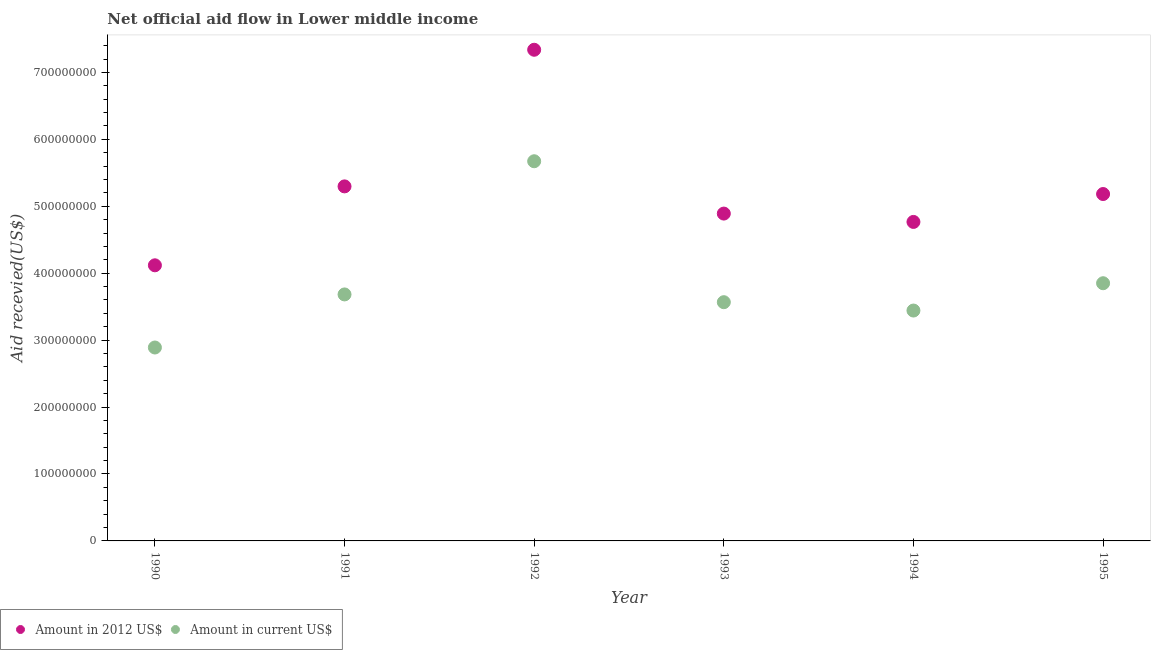Is the number of dotlines equal to the number of legend labels?
Give a very brief answer. Yes. What is the amount of aid received(expressed in 2012 us$) in 1993?
Your answer should be very brief. 4.89e+08. Across all years, what is the maximum amount of aid received(expressed in us$)?
Give a very brief answer. 5.67e+08. Across all years, what is the minimum amount of aid received(expressed in us$)?
Provide a succinct answer. 2.89e+08. In which year was the amount of aid received(expressed in 2012 us$) maximum?
Your answer should be very brief. 1992. In which year was the amount of aid received(expressed in 2012 us$) minimum?
Make the answer very short. 1990. What is the total amount of aid received(expressed in us$) in the graph?
Your answer should be compact. 2.31e+09. What is the difference between the amount of aid received(expressed in 2012 us$) in 1991 and that in 1993?
Provide a succinct answer. 4.06e+07. What is the difference between the amount of aid received(expressed in us$) in 1995 and the amount of aid received(expressed in 2012 us$) in 1992?
Make the answer very short. -3.49e+08. What is the average amount of aid received(expressed in us$) per year?
Your answer should be compact. 3.85e+08. In the year 1990, what is the difference between the amount of aid received(expressed in 2012 us$) and amount of aid received(expressed in us$)?
Ensure brevity in your answer.  1.23e+08. What is the ratio of the amount of aid received(expressed in us$) in 1990 to that in 1995?
Your answer should be compact. 0.75. Is the difference between the amount of aid received(expressed in us$) in 1993 and 1994 greater than the difference between the amount of aid received(expressed in 2012 us$) in 1993 and 1994?
Offer a very short reply. Yes. What is the difference between the highest and the second highest amount of aid received(expressed in us$)?
Offer a terse response. 1.82e+08. What is the difference between the highest and the lowest amount of aid received(expressed in us$)?
Make the answer very short. 2.78e+08. Is the amount of aid received(expressed in 2012 us$) strictly greater than the amount of aid received(expressed in us$) over the years?
Your answer should be very brief. Yes. What is the difference between two consecutive major ticks on the Y-axis?
Ensure brevity in your answer.  1.00e+08. Are the values on the major ticks of Y-axis written in scientific E-notation?
Offer a terse response. No. Where does the legend appear in the graph?
Keep it short and to the point. Bottom left. What is the title of the graph?
Ensure brevity in your answer.  Net official aid flow in Lower middle income. Does "By country of asylum" appear as one of the legend labels in the graph?
Keep it short and to the point. No. What is the label or title of the Y-axis?
Your answer should be very brief. Aid recevied(US$). What is the Aid recevied(US$) of Amount in 2012 US$ in 1990?
Your response must be concise. 4.12e+08. What is the Aid recevied(US$) of Amount in current US$ in 1990?
Keep it short and to the point. 2.89e+08. What is the Aid recevied(US$) in Amount in 2012 US$ in 1991?
Provide a succinct answer. 5.30e+08. What is the Aid recevied(US$) of Amount in current US$ in 1991?
Your answer should be compact. 3.68e+08. What is the Aid recevied(US$) of Amount in 2012 US$ in 1992?
Offer a terse response. 7.34e+08. What is the Aid recevied(US$) in Amount in current US$ in 1992?
Your answer should be compact. 5.67e+08. What is the Aid recevied(US$) in Amount in 2012 US$ in 1993?
Give a very brief answer. 4.89e+08. What is the Aid recevied(US$) of Amount in current US$ in 1993?
Provide a succinct answer. 3.57e+08. What is the Aid recevied(US$) of Amount in 2012 US$ in 1994?
Ensure brevity in your answer.  4.77e+08. What is the Aid recevied(US$) in Amount in current US$ in 1994?
Your answer should be compact. 3.44e+08. What is the Aid recevied(US$) of Amount in 2012 US$ in 1995?
Give a very brief answer. 5.18e+08. What is the Aid recevied(US$) of Amount in current US$ in 1995?
Your response must be concise. 3.85e+08. Across all years, what is the maximum Aid recevied(US$) of Amount in 2012 US$?
Provide a succinct answer. 7.34e+08. Across all years, what is the maximum Aid recevied(US$) of Amount in current US$?
Offer a terse response. 5.67e+08. Across all years, what is the minimum Aid recevied(US$) in Amount in 2012 US$?
Provide a succinct answer. 4.12e+08. Across all years, what is the minimum Aid recevied(US$) in Amount in current US$?
Keep it short and to the point. 2.89e+08. What is the total Aid recevied(US$) of Amount in 2012 US$ in the graph?
Your answer should be compact. 3.16e+09. What is the total Aid recevied(US$) in Amount in current US$ in the graph?
Your answer should be compact. 2.31e+09. What is the difference between the Aid recevied(US$) in Amount in 2012 US$ in 1990 and that in 1991?
Your answer should be very brief. -1.18e+08. What is the difference between the Aid recevied(US$) in Amount in current US$ in 1990 and that in 1991?
Provide a succinct answer. -7.93e+07. What is the difference between the Aid recevied(US$) of Amount in 2012 US$ in 1990 and that in 1992?
Provide a short and direct response. -3.22e+08. What is the difference between the Aid recevied(US$) in Amount in current US$ in 1990 and that in 1992?
Keep it short and to the point. -2.78e+08. What is the difference between the Aid recevied(US$) of Amount in 2012 US$ in 1990 and that in 1993?
Your answer should be very brief. -7.73e+07. What is the difference between the Aid recevied(US$) of Amount in current US$ in 1990 and that in 1993?
Offer a very short reply. -6.77e+07. What is the difference between the Aid recevied(US$) of Amount in 2012 US$ in 1990 and that in 1994?
Your answer should be compact. -6.48e+07. What is the difference between the Aid recevied(US$) of Amount in current US$ in 1990 and that in 1994?
Ensure brevity in your answer.  -5.52e+07. What is the difference between the Aid recevied(US$) in Amount in 2012 US$ in 1990 and that in 1995?
Offer a very short reply. -1.06e+08. What is the difference between the Aid recevied(US$) in Amount in current US$ in 1990 and that in 1995?
Make the answer very short. -9.60e+07. What is the difference between the Aid recevied(US$) of Amount in 2012 US$ in 1991 and that in 1992?
Your answer should be very brief. -2.04e+08. What is the difference between the Aid recevied(US$) in Amount in current US$ in 1991 and that in 1992?
Keep it short and to the point. -1.99e+08. What is the difference between the Aid recevied(US$) in Amount in 2012 US$ in 1991 and that in 1993?
Your answer should be compact. 4.06e+07. What is the difference between the Aid recevied(US$) of Amount in current US$ in 1991 and that in 1993?
Offer a very short reply. 1.16e+07. What is the difference between the Aid recevied(US$) in Amount in 2012 US$ in 1991 and that in 1994?
Make the answer very short. 5.31e+07. What is the difference between the Aid recevied(US$) in Amount in current US$ in 1991 and that in 1994?
Your response must be concise. 2.41e+07. What is the difference between the Aid recevied(US$) in Amount in 2012 US$ in 1991 and that in 1995?
Provide a succinct answer. 1.14e+07. What is the difference between the Aid recevied(US$) in Amount in current US$ in 1991 and that in 1995?
Offer a terse response. -1.67e+07. What is the difference between the Aid recevied(US$) of Amount in 2012 US$ in 1992 and that in 1993?
Provide a short and direct response. 2.45e+08. What is the difference between the Aid recevied(US$) of Amount in current US$ in 1992 and that in 1993?
Your response must be concise. 2.11e+08. What is the difference between the Aid recevied(US$) in Amount in 2012 US$ in 1992 and that in 1994?
Your response must be concise. 2.57e+08. What is the difference between the Aid recevied(US$) of Amount in current US$ in 1992 and that in 1994?
Your response must be concise. 2.23e+08. What is the difference between the Aid recevied(US$) of Amount in 2012 US$ in 1992 and that in 1995?
Your response must be concise. 2.16e+08. What is the difference between the Aid recevied(US$) in Amount in current US$ in 1992 and that in 1995?
Your answer should be compact. 1.82e+08. What is the difference between the Aid recevied(US$) of Amount in 2012 US$ in 1993 and that in 1994?
Offer a very short reply. 1.25e+07. What is the difference between the Aid recevied(US$) of Amount in current US$ in 1993 and that in 1994?
Provide a short and direct response. 1.25e+07. What is the difference between the Aid recevied(US$) in Amount in 2012 US$ in 1993 and that in 1995?
Make the answer very short. -2.92e+07. What is the difference between the Aid recevied(US$) in Amount in current US$ in 1993 and that in 1995?
Give a very brief answer. -2.83e+07. What is the difference between the Aid recevied(US$) in Amount in 2012 US$ in 1994 and that in 1995?
Your response must be concise. -4.17e+07. What is the difference between the Aid recevied(US$) of Amount in current US$ in 1994 and that in 1995?
Give a very brief answer. -4.08e+07. What is the difference between the Aid recevied(US$) in Amount in 2012 US$ in 1990 and the Aid recevied(US$) in Amount in current US$ in 1991?
Your response must be concise. 4.35e+07. What is the difference between the Aid recevied(US$) of Amount in 2012 US$ in 1990 and the Aid recevied(US$) of Amount in current US$ in 1992?
Your answer should be very brief. -1.55e+08. What is the difference between the Aid recevied(US$) of Amount in 2012 US$ in 1990 and the Aid recevied(US$) of Amount in current US$ in 1993?
Your answer should be very brief. 5.51e+07. What is the difference between the Aid recevied(US$) of Amount in 2012 US$ in 1990 and the Aid recevied(US$) of Amount in current US$ in 1994?
Your answer should be very brief. 6.76e+07. What is the difference between the Aid recevied(US$) in Amount in 2012 US$ in 1990 and the Aid recevied(US$) in Amount in current US$ in 1995?
Keep it short and to the point. 2.68e+07. What is the difference between the Aid recevied(US$) in Amount in 2012 US$ in 1991 and the Aid recevied(US$) in Amount in current US$ in 1992?
Your answer should be very brief. -3.76e+07. What is the difference between the Aid recevied(US$) of Amount in 2012 US$ in 1991 and the Aid recevied(US$) of Amount in current US$ in 1993?
Your answer should be compact. 1.73e+08. What is the difference between the Aid recevied(US$) in Amount in 2012 US$ in 1991 and the Aid recevied(US$) in Amount in current US$ in 1994?
Keep it short and to the point. 1.86e+08. What is the difference between the Aid recevied(US$) in Amount in 2012 US$ in 1991 and the Aid recevied(US$) in Amount in current US$ in 1995?
Provide a short and direct response. 1.45e+08. What is the difference between the Aid recevied(US$) in Amount in 2012 US$ in 1992 and the Aid recevied(US$) in Amount in current US$ in 1993?
Keep it short and to the point. 3.77e+08. What is the difference between the Aid recevied(US$) in Amount in 2012 US$ in 1992 and the Aid recevied(US$) in Amount in current US$ in 1994?
Your response must be concise. 3.90e+08. What is the difference between the Aid recevied(US$) of Amount in 2012 US$ in 1992 and the Aid recevied(US$) of Amount in current US$ in 1995?
Offer a terse response. 3.49e+08. What is the difference between the Aid recevied(US$) in Amount in 2012 US$ in 1993 and the Aid recevied(US$) in Amount in current US$ in 1994?
Provide a succinct answer. 1.45e+08. What is the difference between the Aid recevied(US$) in Amount in 2012 US$ in 1993 and the Aid recevied(US$) in Amount in current US$ in 1995?
Provide a short and direct response. 1.04e+08. What is the difference between the Aid recevied(US$) of Amount in 2012 US$ in 1994 and the Aid recevied(US$) of Amount in current US$ in 1995?
Your answer should be very brief. 9.16e+07. What is the average Aid recevied(US$) in Amount in 2012 US$ per year?
Offer a terse response. 5.27e+08. What is the average Aid recevied(US$) of Amount in current US$ per year?
Keep it short and to the point. 3.85e+08. In the year 1990, what is the difference between the Aid recevied(US$) of Amount in 2012 US$ and Aid recevied(US$) of Amount in current US$?
Give a very brief answer. 1.23e+08. In the year 1991, what is the difference between the Aid recevied(US$) of Amount in 2012 US$ and Aid recevied(US$) of Amount in current US$?
Provide a short and direct response. 1.61e+08. In the year 1992, what is the difference between the Aid recevied(US$) in Amount in 2012 US$ and Aid recevied(US$) in Amount in current US$?
Offer a very short reply. 1.67e+08. In the year 1993, what is the difference between the Aid recevied(US$) in Amount in 2012 US$ and Aid recevied(US$) in Amount in current US$?
Your answer should be compact. 1.32e+08. In the year 1994, what is the difference between the Aid recevied(US$) of Amount in 2012 US$ and Aid recevied(US$) of Amount in current US$?
Give a very brief answer. 1.32e+08. In the year 1995, what is the difference between the Aid recevied(US$) in Amount in 2012 US$ and Aid recevied(US$) in Amount in current US$?
Ensure brevity in your answer.  1.33e+08. What is the ratio of the Aid recevied(US$) of Amount in 2012 US$ in 1990 to that in 1991?
Give a very brief answer. 0.78. What is the ratio of the Aid recevied(US$) in Amount in current US$ in 1990 to that in 1991?
Offer a terse response. 0.78. What is the ratio of the Aid recevied(US$) in Amount in 2012 US$ in 1990 to that in 1992?
Give a very brief answer. 0.56. What is the ratio of the Aid recevied(US$) in Amount in current US$ in 1990 to that in 1992?
Your answer should be compact. 0.51. What is the ratio of the Aid recevied(US$) of Amount in 2012 US$ in 1990 to that in 1993?
Make the answer very short. 0.84. What is the ratio of the Aid recevied(US$) of Amount in current US$ in 1990 to that in 1993?
Give a very brief answer. 0.81. What is the ratio of the Aid recevied(US$) in Amount in 2012 US$ in 1990 to that in 1994?
Ensure brevity in your answer.  0.86. What is the ratio of the Aid recevied(US$) of Amount in current US$ in 1990 to that in 1994?
Your answer should be very brief. 0.84. What is the ratio of the Aid recevied(US$) in Amount in 2012 US$ in 1990 to that in 1995?
Keep it short and to the point. 0.79. What is the ratio of the Aid recevied(US$) in Amount in current US$ in 1990 to that in 1995?
Your response must be concise. 0.75. What is the ratio of the Aid recevied(US$) of Amount in 2012 US$ in 1991 to that in 1992?
Your response must be concise. 0.72. What is the ratio of the Aid recevied(US$) of Amount in current US$ in 1991 to that in 1992?
Give a very brief answer. 0.65. What is the ratio of the Aid recevied(US$) in Amount in 2012 US$ in 1991 to that in 1993?
Keep it short and to the point. 1.08. What is the ratio of the Aid recevied(US$) in Amount in current US$ in 1991 to that in 1993?
Keep it short and to the point. 1.03. What is the ratio of the Aid recevied(US$) in Amount in 2012 US$ in 1991 to that in 1994?
Your answer should be very brief. 1.11. What is the ratio of the Aid recevied(US$) of Amount in current US$ in 1991 to that in 1994?
Provide a short and direct response. 1.07. What is the ratio of the Aid recevied(US$) of Amount in current US$ in 1991 to that in 1995?
Offer a very short reply. 0.96. What is the ratio of the Aid recevied(US$) of Amount in 2012 US$ in 1992 to that in 1993?
Give a very brief answer. 1.5. What is the ratio of the Aid recevied(US$) of Amount in current US$ in 1992 to that in 1993?
Ensure brevity in your answer.  1.59. What is the ratio of the Aid recevied(US$) of Amount in 2012 US$ in 1992 to that in 1994?
Provide a succinct answer. 1.54. What is the ratio of the Aid recevied(US$) in Amount in current US$ in 1992 to that in 1994?
Ensure brevity in your answer.  1.65. What is the ratio of the Aid recevied(US$) of Amount in 2012 US$ in 1992 to that in 1995?
Make the answer very short. 1.42. What is the ratio of the Aid recevied(US$) in Amount in current US$ in 1992 to that in 1995?
Your response must be concise. 1.47. What is the ratio of the Aid recevied(US$) in Amount in 2012 US$ in 1993 to that in 1994?
Your answer should be very brief. 1.03. What is the ratio of the Aid recevied(US$) of Amount in current US$ in 1993 to that in 1994?
Your response must be concise. 1.04. What is the ratio of the Aid recevied(US$) in Amount in 2012 US$ in 1993 to that in 1995?
Offer a very short reply. 0.94. What is the ratio of the Aid recevied(US$) in Amount in current US$ in 1993 to that in 1995?
Offer a terse response. 0.93. What is the ratio of the Aid recevied(US$) of Amount in 2012 US$ in 1994 to that in 1995?
Offer a very short reply. 0.92. What is the ratio of the Aid recevied(US$) in Amount in current US$ in 1994 to that in 1995?
Ensure brevity in your answer.  0.89. What is the difference between the highest and the second highest Aid recevied(US$) of Amount in 2012 US$?
Give a very brief answer. 2.04e+08. What is the difference between the highest and the second highest Aid recevied(US$) in Amount in current US$?
Your response must be concise. 1.82e+08. What is the difference between the highest and the lowest Aid recevied(US$) in Amount in 2012 US$?
Your response must be concise. 3.22e+08. What is the difference between the highest and the lowest Aid recevied(US$) of Amount in current US$?
Offer a very short reply. 2.78e+08. 